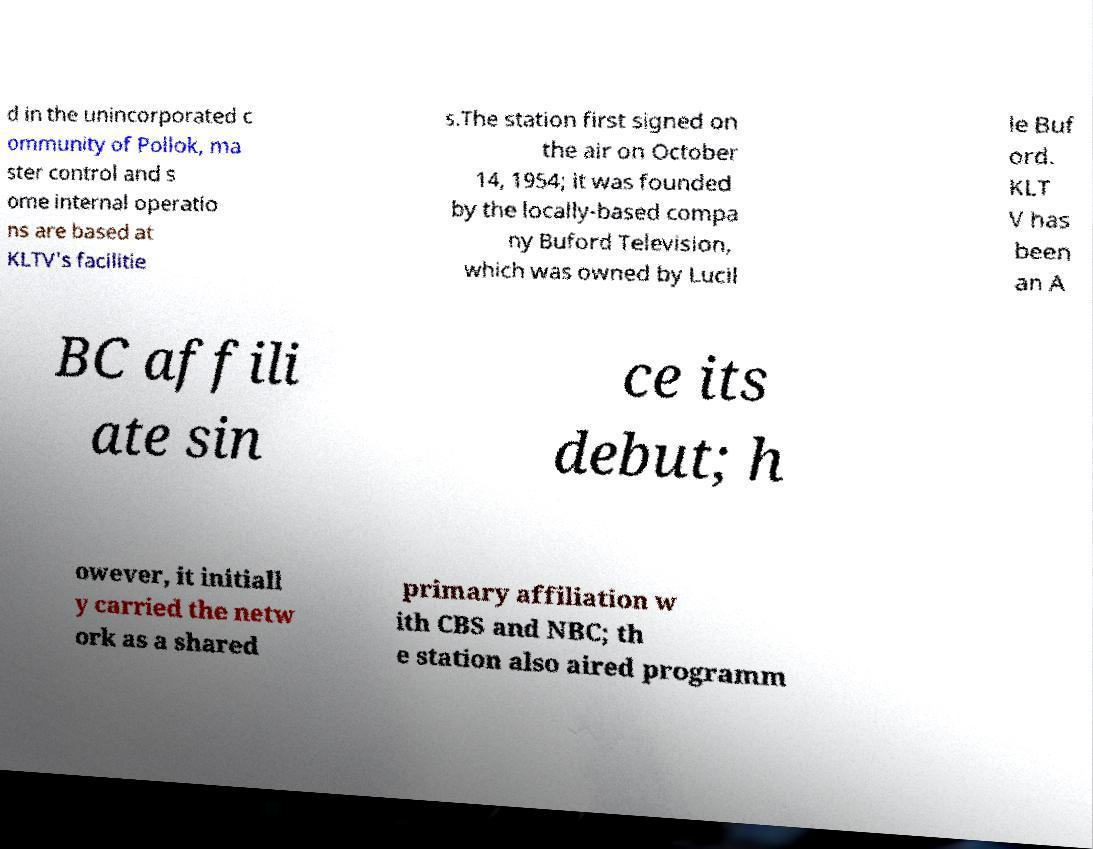There's text embedded in this image that I need extracted. Can you transcribe it verbatim? d in the unincorporated c ommunity of Pollok, ma ster control and s ome internal operatio ns are based at KLTV's facilitie s.The station first signed on the air on October 14, 1954; it was founded by the locally-based compa ny Buford Television, which was owned by Lucil le Buf ord. KLT V has been an A BC affili ate sin ce its debut; h owever, it initiall y carried the netw ork as a shared primary affiliation w ith CBS and NBC; th e station also aired programm 